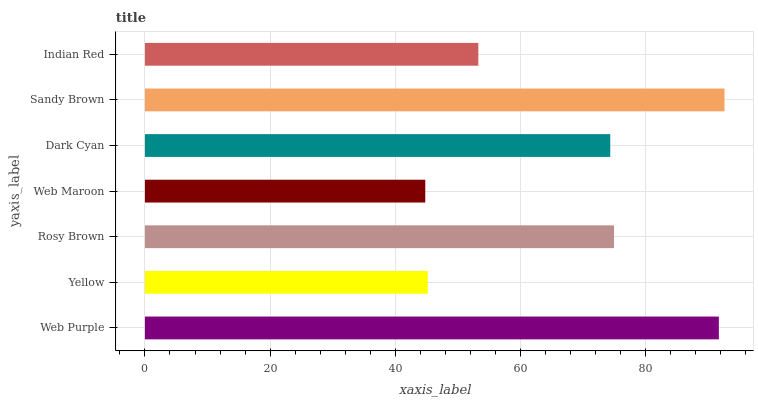Is Web Maroon the minimum?
Answer yes or no. Yes. Is Sandy Brown the maximum?
Answer yes or no. Yes. Is Yellow the minimum?
Answer yes or no. No. Is Yellow the maximum?
Answer yes or no. No. Is Web Purple greater than Yellow?
Answer yes or no. Yes. Is Yellow less than Web Purple?
Answer yes or no. Yes. Is Yellow greater than Web Purple?
Answer yes or no. No. Is Web Purple less than Yellow?
Answer yes or no. No. Is Dark Cyan the high median?
Answer yes or no. Yes. Is Dark Cyan the low median?
Answer yes or no. Yes. Is Rosy Brown the high median?
Answer yes or no. No. Is Sandy Brown the low median?
Answer yes or no. No. 